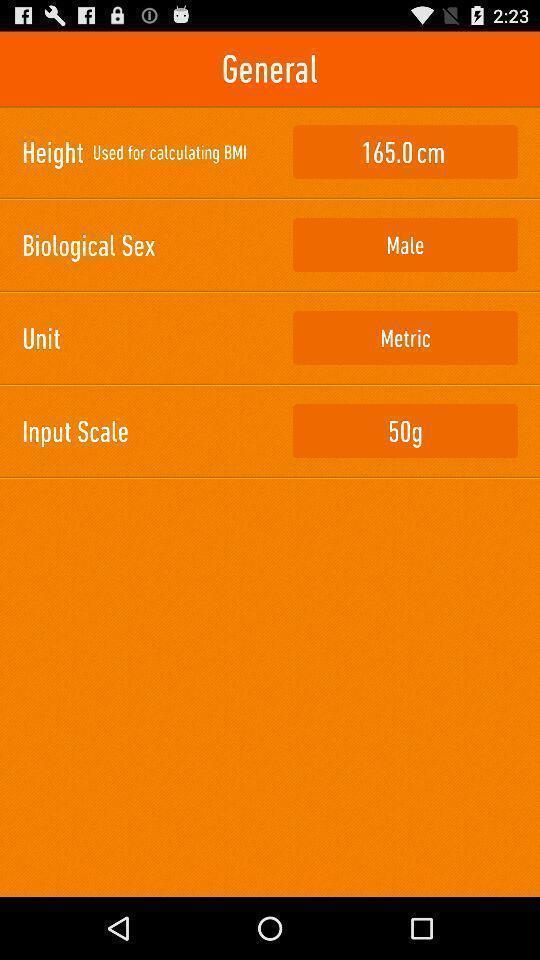Provide a description of this screenshot. Page displaying list of general information in app. 